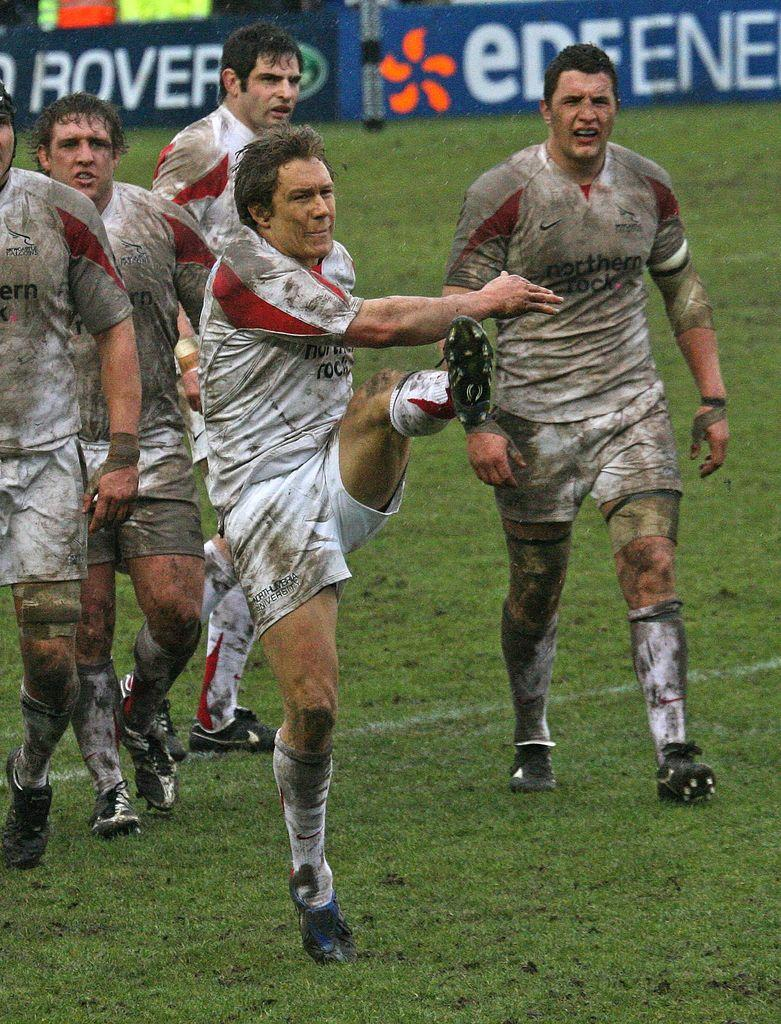What is happening in the image? There are people on the ground in the image. What can be seen in the background of the image? There are boards with text in the background of the image. What type of juice is being served to the toad in the image? There is no toad or juice present in the image. What is the air quality like in the image? The provided facts do not give any information about the air quality in the image. 